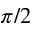<formula> <loc_0><loc_0><loc_500><loc_500>\pi / 2</formula> 